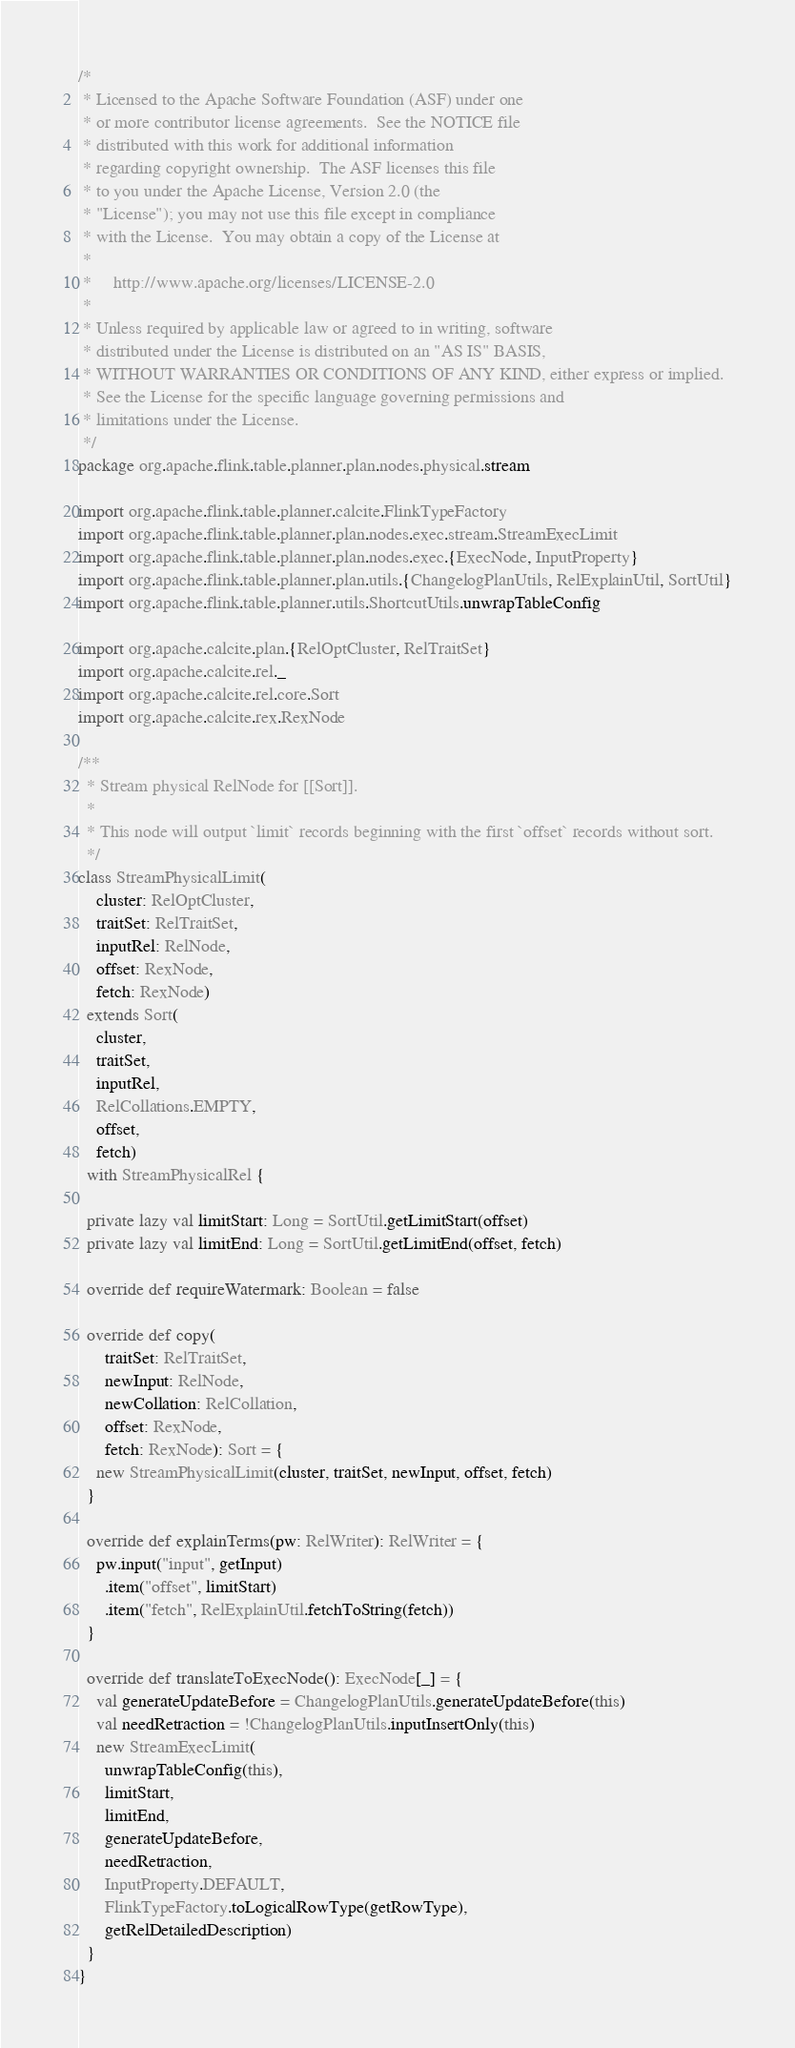Convert code to text. <code><loc_0><loc_0><loc_500><loc_500><_Scala_>/*
 * Licensed to the Apache Software Foundation (ASF) under one
 * or more contributor license agreements.  See the NOTICE file
 * distributed with this work for additional information
 * regarding copyright ownership.  The ASF licenses this file
 * to you under the Apache License, Version 2.0 (the
 * "License"); you may not use this file except in compliance
 * with the License.  You may obtain a copy of the License at
 *
 *     http://www.apache.org/licenses/LICENSE-2.0
 *
 * Unless required by applicable law or agreed to in writing, software
 * distributed under the License is distributed on an "AS IS" BASIS,
 * WITHOUT WARRANTIES OR CONDITIONS OF ANY KIND, either express or implied.
 * See the License for the specific language governing permissions and
 * limitations under the License.
 */
package org.apache.flink.table.planner.plan.nodes.physical.stream

import org.apache.flink.table.planner.calcite.FlinkTypeFactory
import org.apache.flink.table.planner.plan.nodes.exec.stream.StreamExecLimit
import org.apache.flink.table.planner.plan.nodes.exec.{ExecNode, InputProperty}
import org.apache.flink.table.planner.plan.utils.{ChangelogPlanUtils, RelExplainUtil, SortUtil}
import org.apache.flink.table.planner.utils.ShortcutUtils.unwrapTableConfig

import org.apache.calcite.plan.{RelOptCluster, RelTraitSet}
import org.apache.calcite.rel._
import org.apache.calcite.rel.core.Sort
import org.apache.calcite.rex.RexNode

/**
  * Stream physical RelNode for [[Sort]].
  *
  * This node will output `limit` records beginning with the first `offset` records without sort.
  */
class StreamPhysicalLimit(
    cluster: RelOptCluster,
    traitSet: RelTraitSet,
    inputRel: RelNode,
    offset: RexNode,
    fetch: RexNode)
  extends Sort(
    cluster,
    traitSet,
    inputRel,
    RelCollations.EMPTY,
    offset,
    fetch)
  with StreamPhysicalRel {

  private lazy val limitStart: Long = SortUtil.getLimitStart(offset)
  private lazy val limitEnd: Long = SortUtil.getLimitEnd(offset, fetch)

  override def requireWatermark: Boolean = false

  override def copy(
      traitSet: RelTraitSet,
      newInput: RelNode,
      newCollation: RelCollation,
      offset: RexNode,
      fetch: RexNode): Sort = {
    new StreamPhysicalLimit(cluster, traitSet, newInput, offset, fetch)
  }

  override def explainTerms(pw: RelWriter): RelWriter = {
    pw.input("input", getInput)
      .item("offset", limitStart)
      .item("fetch", RelExplainUtil.fetchToString(fetch))
  }

  override def translateToExecNode(): ExecNode[_] = {
    val generateUpdateBefore = ChangelogPlanUtils.generateUpdateBefore(this)
    val needRetraction = !ChangelogPlanUtils.inputInsertOnly(this)
    new StreamExecLimit(
      unwrapTableConfig(this),
      limitStart,
      limitEnd,
      generateUpdateBefore,
      needRetraction,
      InputProperty.DEFAULT,
      FlinkTypeFactory.toLogicalRowType(getRowType),
      getRelDetailedDescription)
  }
}
</code> 